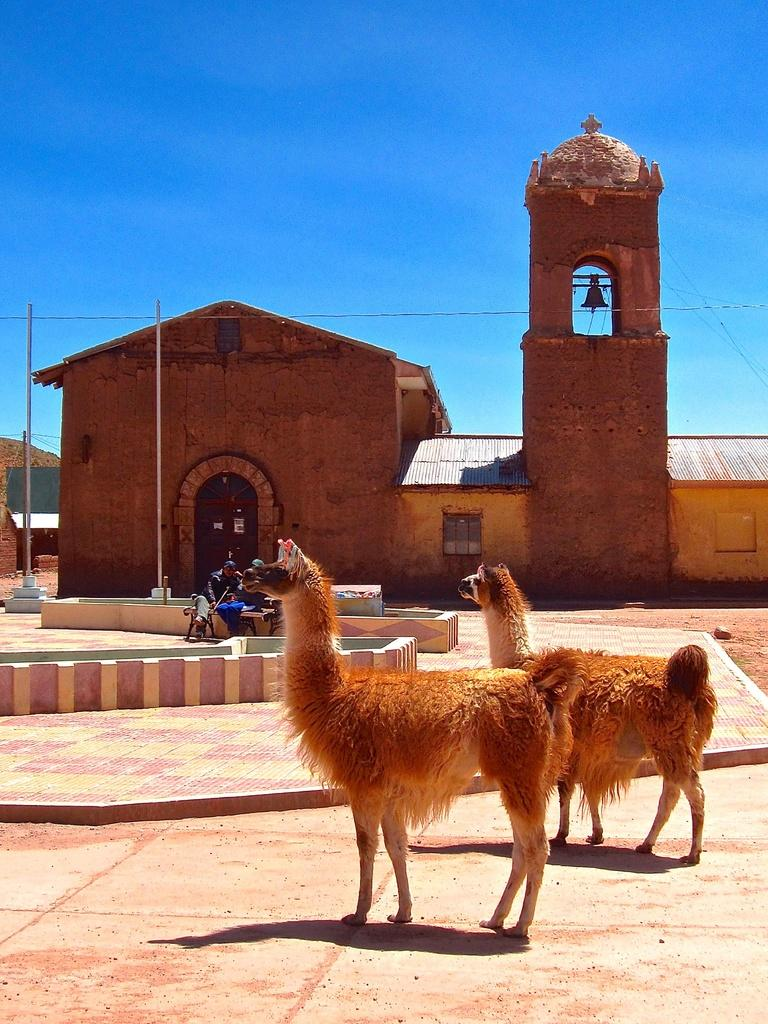How many llamas are in the image? There are two llamas in the image. Where are the llamas located in the image? The llamas are standing on the floor. What can be seen on the right side of the building in the image? There is a tower on the right side of the building. What is on top of the tower in the image? There is a bell on top of the tower. What is visible above the building and tower in the image? The sky is visible above the building and tower. Can you tell me how many geese are flying in the image? There are no geese present in the image. What color is the girl's nose in the image? There is no girl present in the image. 